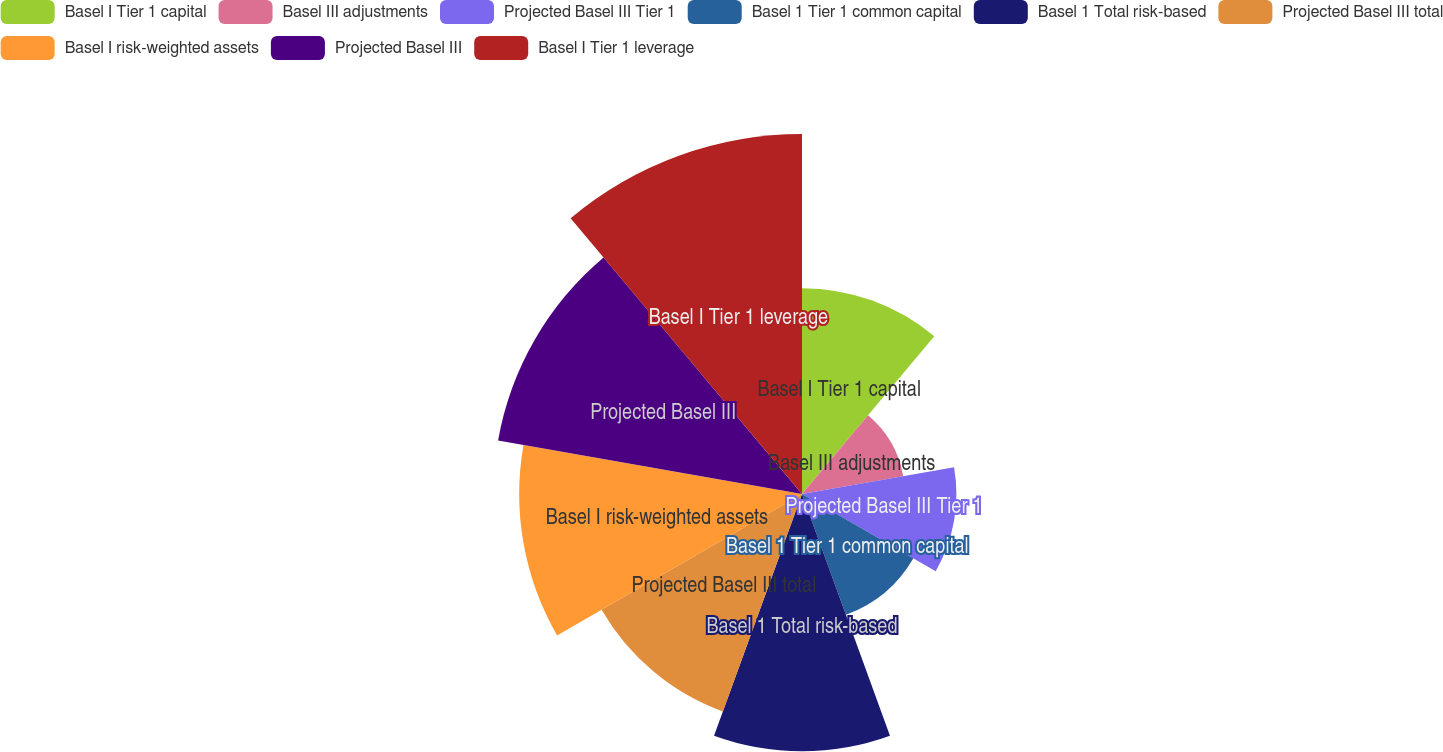Convert chart. <chart><loc_0><loc_0><loc_500><loc_500><pie_chart><fcel>Basel I Tier 1 capital<fcel>Basel III adjustments<fcel>Projected Basel III Tier 1<fcel>Basel 1 Tier 1 common capital<fcel>Basel 1 Total risk-based<fcel>Projected Basel III total<fcel>Basel I risk-weighted assets<fcel>Projected Basel III<fcel>Basel I Tier 1 leverage<nl><fcel>10.13%<fcel>5.06%<fcel>7.6%<fcel>6.33%<fcel>12.66%<fcel>11.39%<fcel>13.92%<fcel>15.19%<fcel>17.72%<nl></chart> 